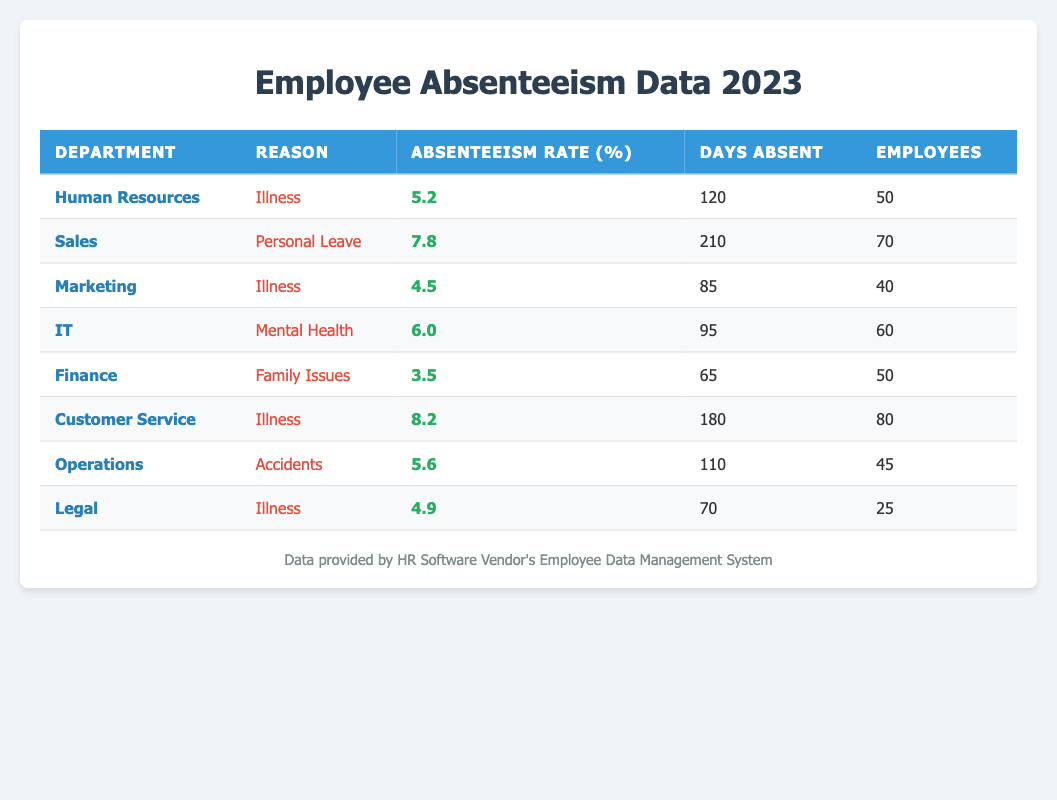What is the absenteeism rate for the Sales department? The absenteeism rate for the Sales department is listed directly in the table, under the relevant row. It shows an absenteeism rate of 7.8%.
Answer: 7.8% Which department has the highest absenteeism rate and what is that rate? By reviewing the absenteeism rates in the table, Customer Service has the highest absenteeism rate at 8.2%.
Answer: Customer Service, 8.2% How many total days were absent across all departments for 'Illness'? The days absent due to 'Illness' are summed from the relevant rows in the table: Human Resources (120) + Marketing (85) + Customer Service (180) + Legal (70) = 455 days.
Answer: 455 Does the Operations department have an absenteeism rate above 5%? The absenteeism rate for the Operations department is listed as 5.6% in the table. Since 5.6% is greater than 5%, the statement is true.
Answer: Yes What is the average absenteeism rate for departments with 'Illness' as a reason? The absenteeism rates for 'Illness' come from three departments: 5.2% (HR), 4.5% (Marketing), 8.2% (Customer Service), and 4.9% (Legal). The average is calculated as (5.2 + 4.5 + 8.2 + 4.9) / 4 = 5.45%.
Answer: 5.45% How many employees in total were absent for 'Mental Health'? Referring to the table, the number of employees who were absent for 'Mental Health' in the IT department is 60. Since there's only one entry for this reason, the total is 60.
Answer: 60 Is the absenteeism rate for Finance higher than that of Marketing? The Finance department has an absenteeism rate of 3.5%, while Marketing has an absenteeism rate of 4.5%. Since 3.5% is less than 4.5%, the statement is false.
Answer: No Which department has the lowest absenteeism rate, and what is the reason for this? By comparing absenteeism rates, the Finance department has the lowest rate at 3.5%, attributed to 'Family Issues'.
Answer: Finance, Family Issues 